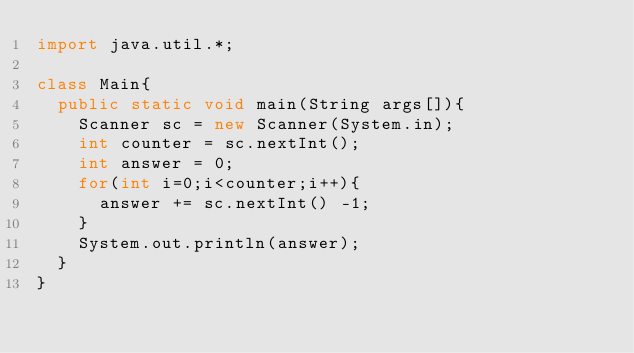Convert code to text. <code><loc_0><loc_0><loc_500><loc_500><_Java_>import java.util.*;

class Main{
  public static void main(String args[]){
    Scanner sc = new Scanner(System.in);
    int counter = sc.nextInt();
    int answer = 0;
    for(int i=0;i<counter;i++){
      answer += sc.nextInt() -1;
    }
    System.out.println(answer);
  }
}</code> 